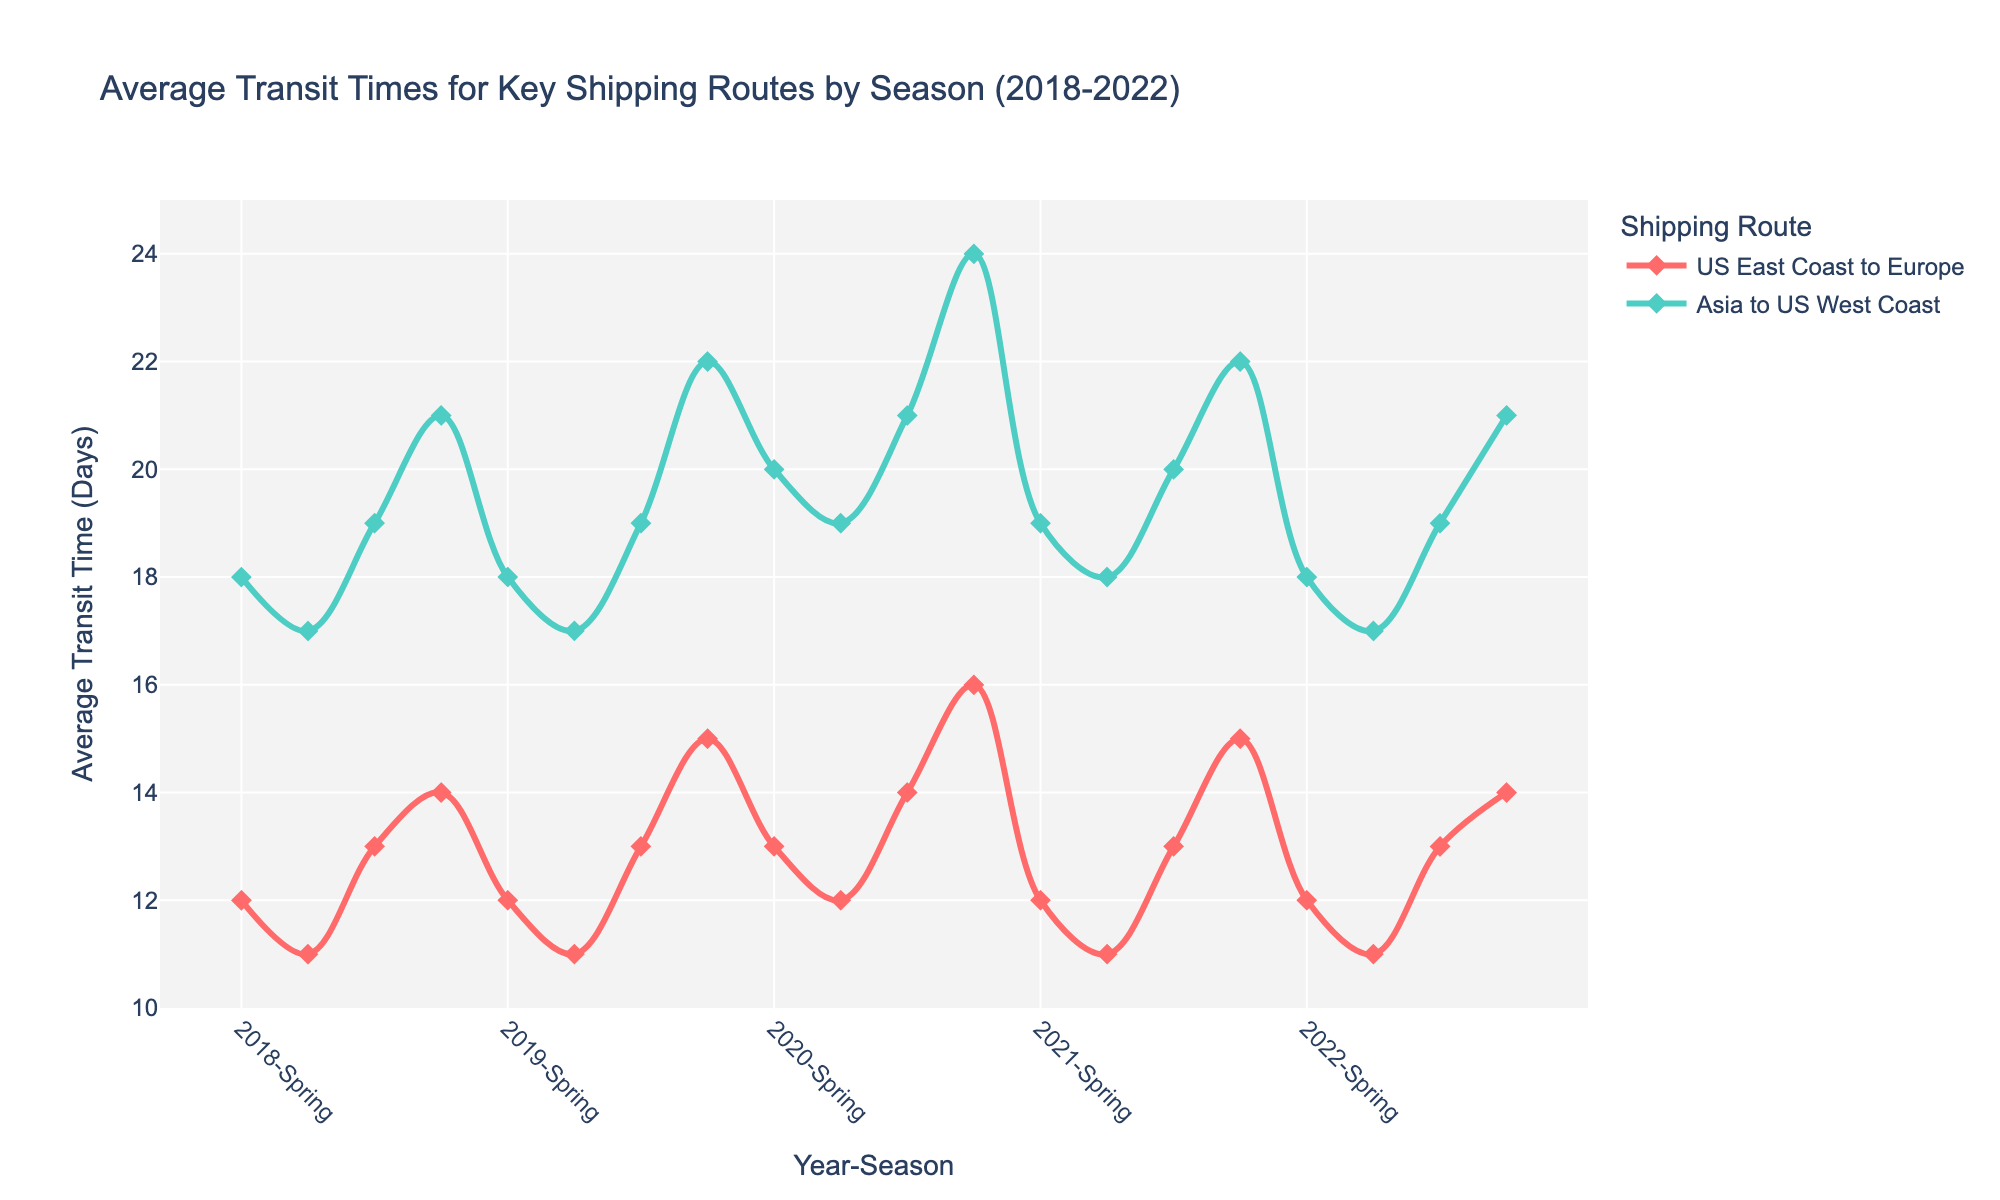What is the overall trend in average transit times for the route from the US East Coast to Europe in Winter over the years? The figure shows the transit times for each season over multiple years. Observing the points for 'Winter' on the US East Coast to Europe line, we see a steady increase from 14 days in 2018 to 15 days in 2019, then 16 days in 2020, back to 15 days in 2021, and finally 14 days in 2022.
Answer: The trend is upward until 2020, then it decreases back to 2018 levels by 2022 Which route consistently has a higher average transit time in Winter? By visually comparing the Winter data points on both lines, the 'Asia to US West Coast' route shows higher transit times (ranging from 21 to 24 days) compared to 'US East Coast to Europe' (ranging from 14 to 16 days).
Answer: Asia to US West Coast What is the biggest difference in average transit times for the 'Asia to US West Coast' route between consecutive years during Winter? Looking at the Winter data points on the 'Asia to US West Coast' line, the largest difference is between 2019 (22 days) and 2020 (24 days), which is an increase of 2 days.
Answer: 2 days How does the average transit time for the 'US East Coast to Europe' route change from Spring to Summer in 2020? In 2020, the data points show an average transit time of 13 days in Spring and 12 days in Summer. The change is a decrease of 1 day.
Answer: Decreases by 1 day Comparing Fall season, which year had the highest average transit time for the 'US East Coast to Europe' route? The Fall data points for 'US East Coast to Europe' show 13 days in 2018, 2019, 2021, and 2022, but 14 days in 2020, which is the highest.
Answer: 2020 Which route shows more variability in average transit times over the years? By comparing the range of transit times for both routes, we see that 'Asia to US West Coast' spans from 17 to 24 days, a wider range than 'US East Coast to Europe', which spans from 11 to 16 days, indicating higher variability.
Answer: Asia to US West Coast In which season and year did the 'US East Coast to Europe' route have its shortest average transit time, and what was it? The shortest average transit time for 'US East Coast to Europe' is 11 days, occurring in the Summer seasons of 2018, 2019, 2021, and 2022.
Answer: Summer of 2018, 2019, 2021, and 2022 Is there any year where the average transit times for both routes in Fall are equal? By examining each Fall data point for both routes across the years, it is apparent that there is no year where the transit times are equal.
Answer: No What's the average rate of change in transit time for the 'Asia to US West Coast' route from Winter 2018 to Winter 2022? The transit time increases from 21 days in Winter 2018 to 22 days in Winter 2019, then to 24 days in Winter 2020, and finally decreases back to 21 days in Winter 2022. To find the average rate of change over 4 years: ((22-21) + (24-22) + (22-24) + (21-22)) / 4 = (1 + 2 - 2 - 1)/4 = 0/4 = 0
Answer: 0 